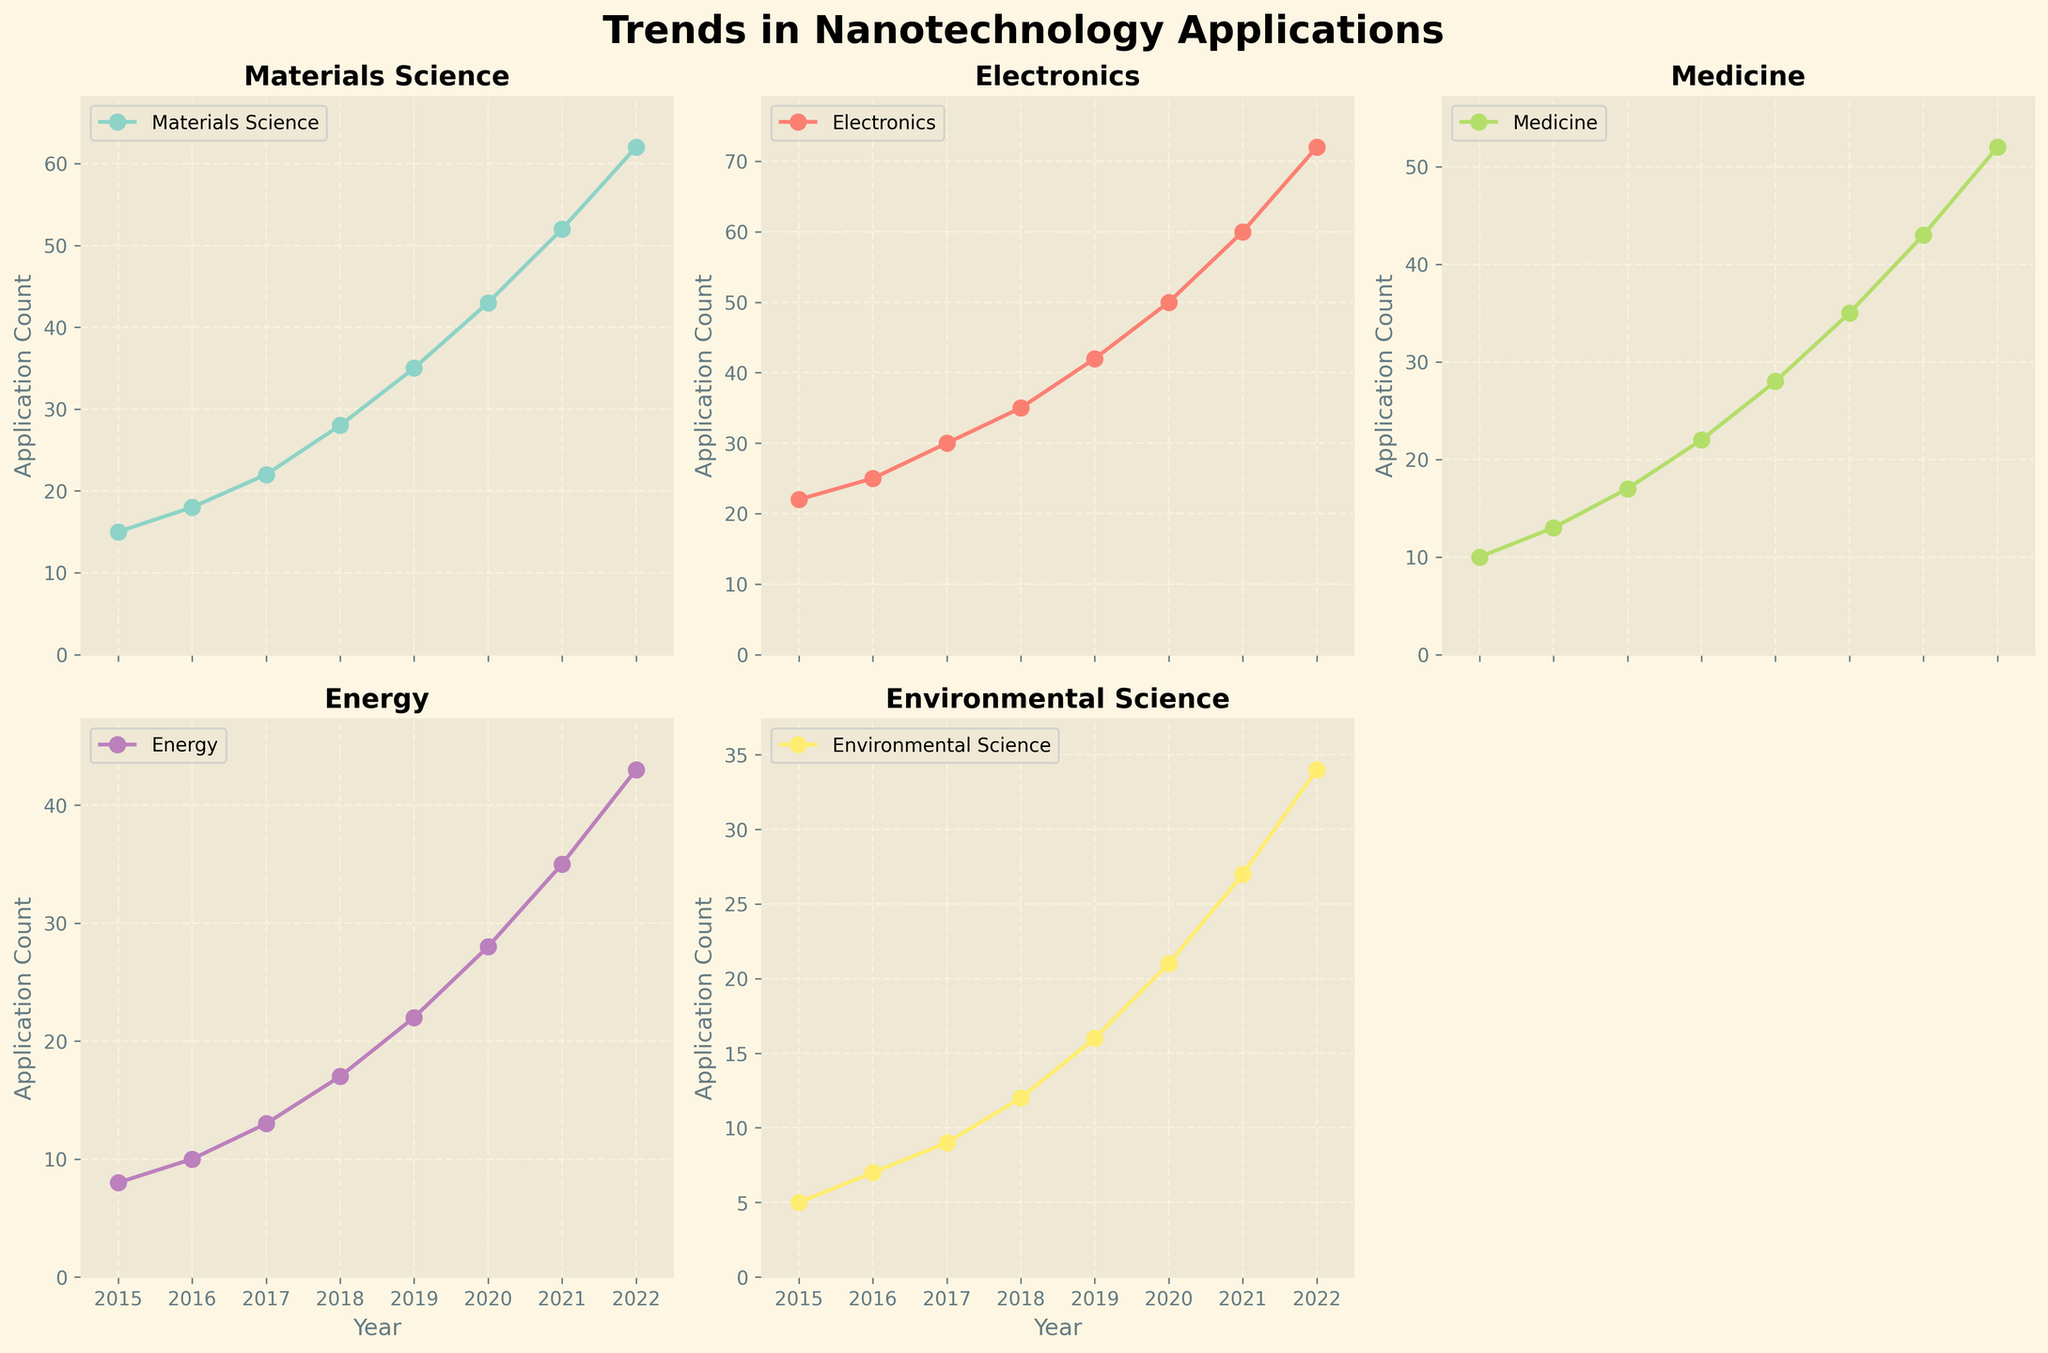How many different fields of nanotechnology applications are plotted? To find the number of fields plotted, observe the number of distinct plots within the grid.
Answer: 5 What is the title of the figure? The title of the figure is found at the top, usually centered and in bold.
Answer: Trends in Nanotechnology Applications In which year did Electronics surpass 50 applications? To determine this, look at the plot for Electronics and find the year when the value crosses 50 on the y-axis.
Answer: 2020 What is the trend of applications in Medicine from 2015 to 2022? Trace the line for Medicine across the years and describe the overall direction of the plot.
Answer: Increasing Between which consecutive years did Environmental Science see the largest increase in applications? Calculate the year-to-year difference in the values for Environmental Science and determine the pair with the maximum increase.
Answer: 2021 to 2022 Which field had the greatest number of applications in 2022? Observe the endpoints for 2022 on each line plot and compare the values.
Answer: Electronics What is the average number of applications in Materials Science from 2015 to 2022? Sum the values for Materials Science across these years and divide by the number of years.
Answer: 34 (average) Comparing 2019 to 2022, which field showed the highest rate of growth? Determine the difference in applications for each field between these years, and identify the field with the largest increase.
Answer: Electronics How does the application trend in Energy compare to that in Environmental Science? Look at the overall patterns in the line plots for Energy and Environmental Science, noting the growth trends over the years.
Answer: Both are increasing, with Energy generally having higher values What is the median application count of Medicine between 2015 and 2022? List the Medicine application counts for these years, sort them, and find the median.
Answer: 22.5 